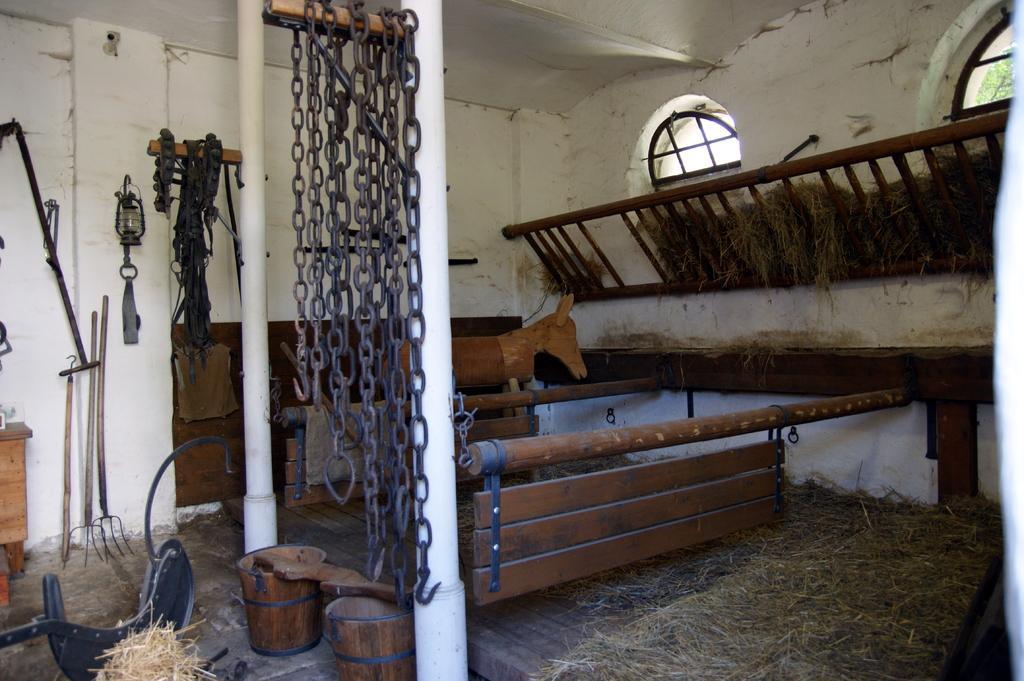Can you describe this image briefly? In this image, we can see the ground with some objects. We can also see some wooden objects, chains and a few metal objects. We can also see some dried grass. We can see the wall with some objects attached to it. 